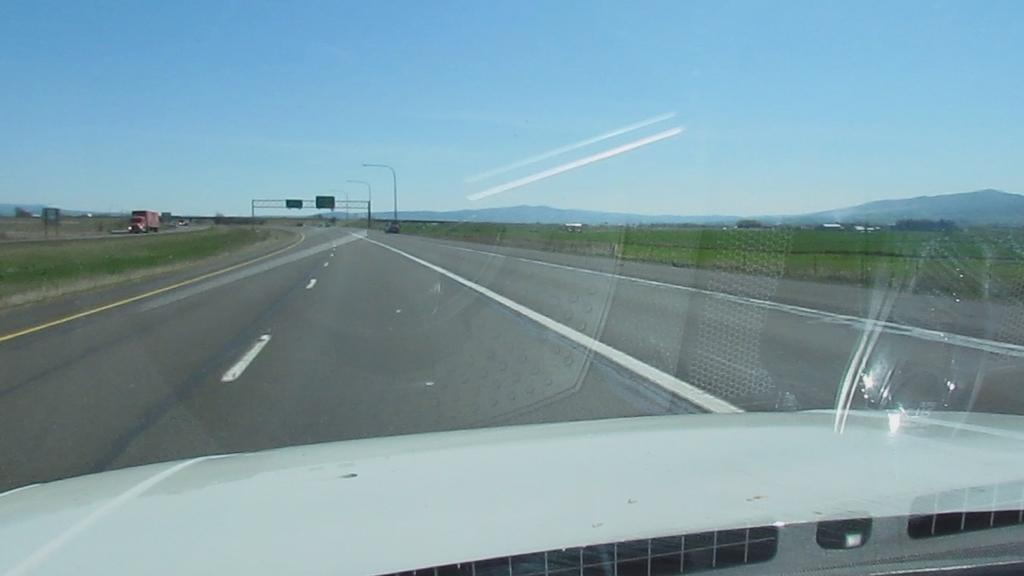Where was the image taken? The image was taken on a highway. What can be seen on either side of the road? There is grassland on either side of the road. What is happening in the background of the image? There is a vehicle moving in the background. What structures are visible in the background? There are poles visible in the background. What natural features can be seen in the distance? There are mountains in the background. What else is visible in the background? The sky is visible in the background. What type of cream is being used to paint the camp in the image? There is no camp or painting activity present in the image. 